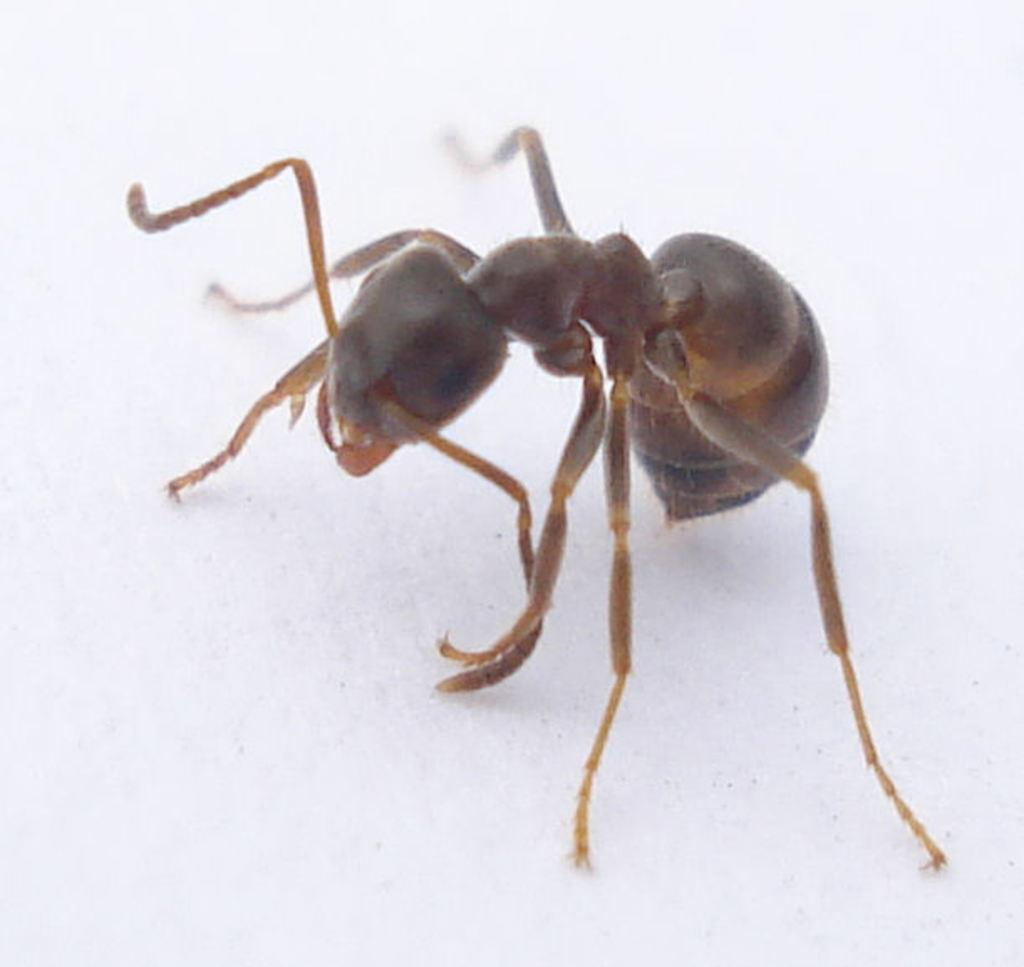What is the main subject of the image? There is an ant in the image. What color is the background of the image? The background of the image is white. How many birds are flying in the fog in the image? There are no birds or fog present in the image; it features an ant on a white background. 